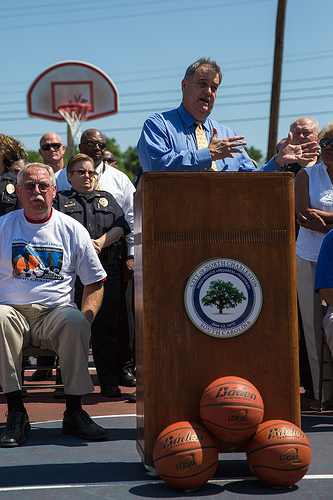<image>
Can you confirm if the ball is under the podium? Yes. The ball is positioned underneath the podium, with the podium above it in the vertical space. 